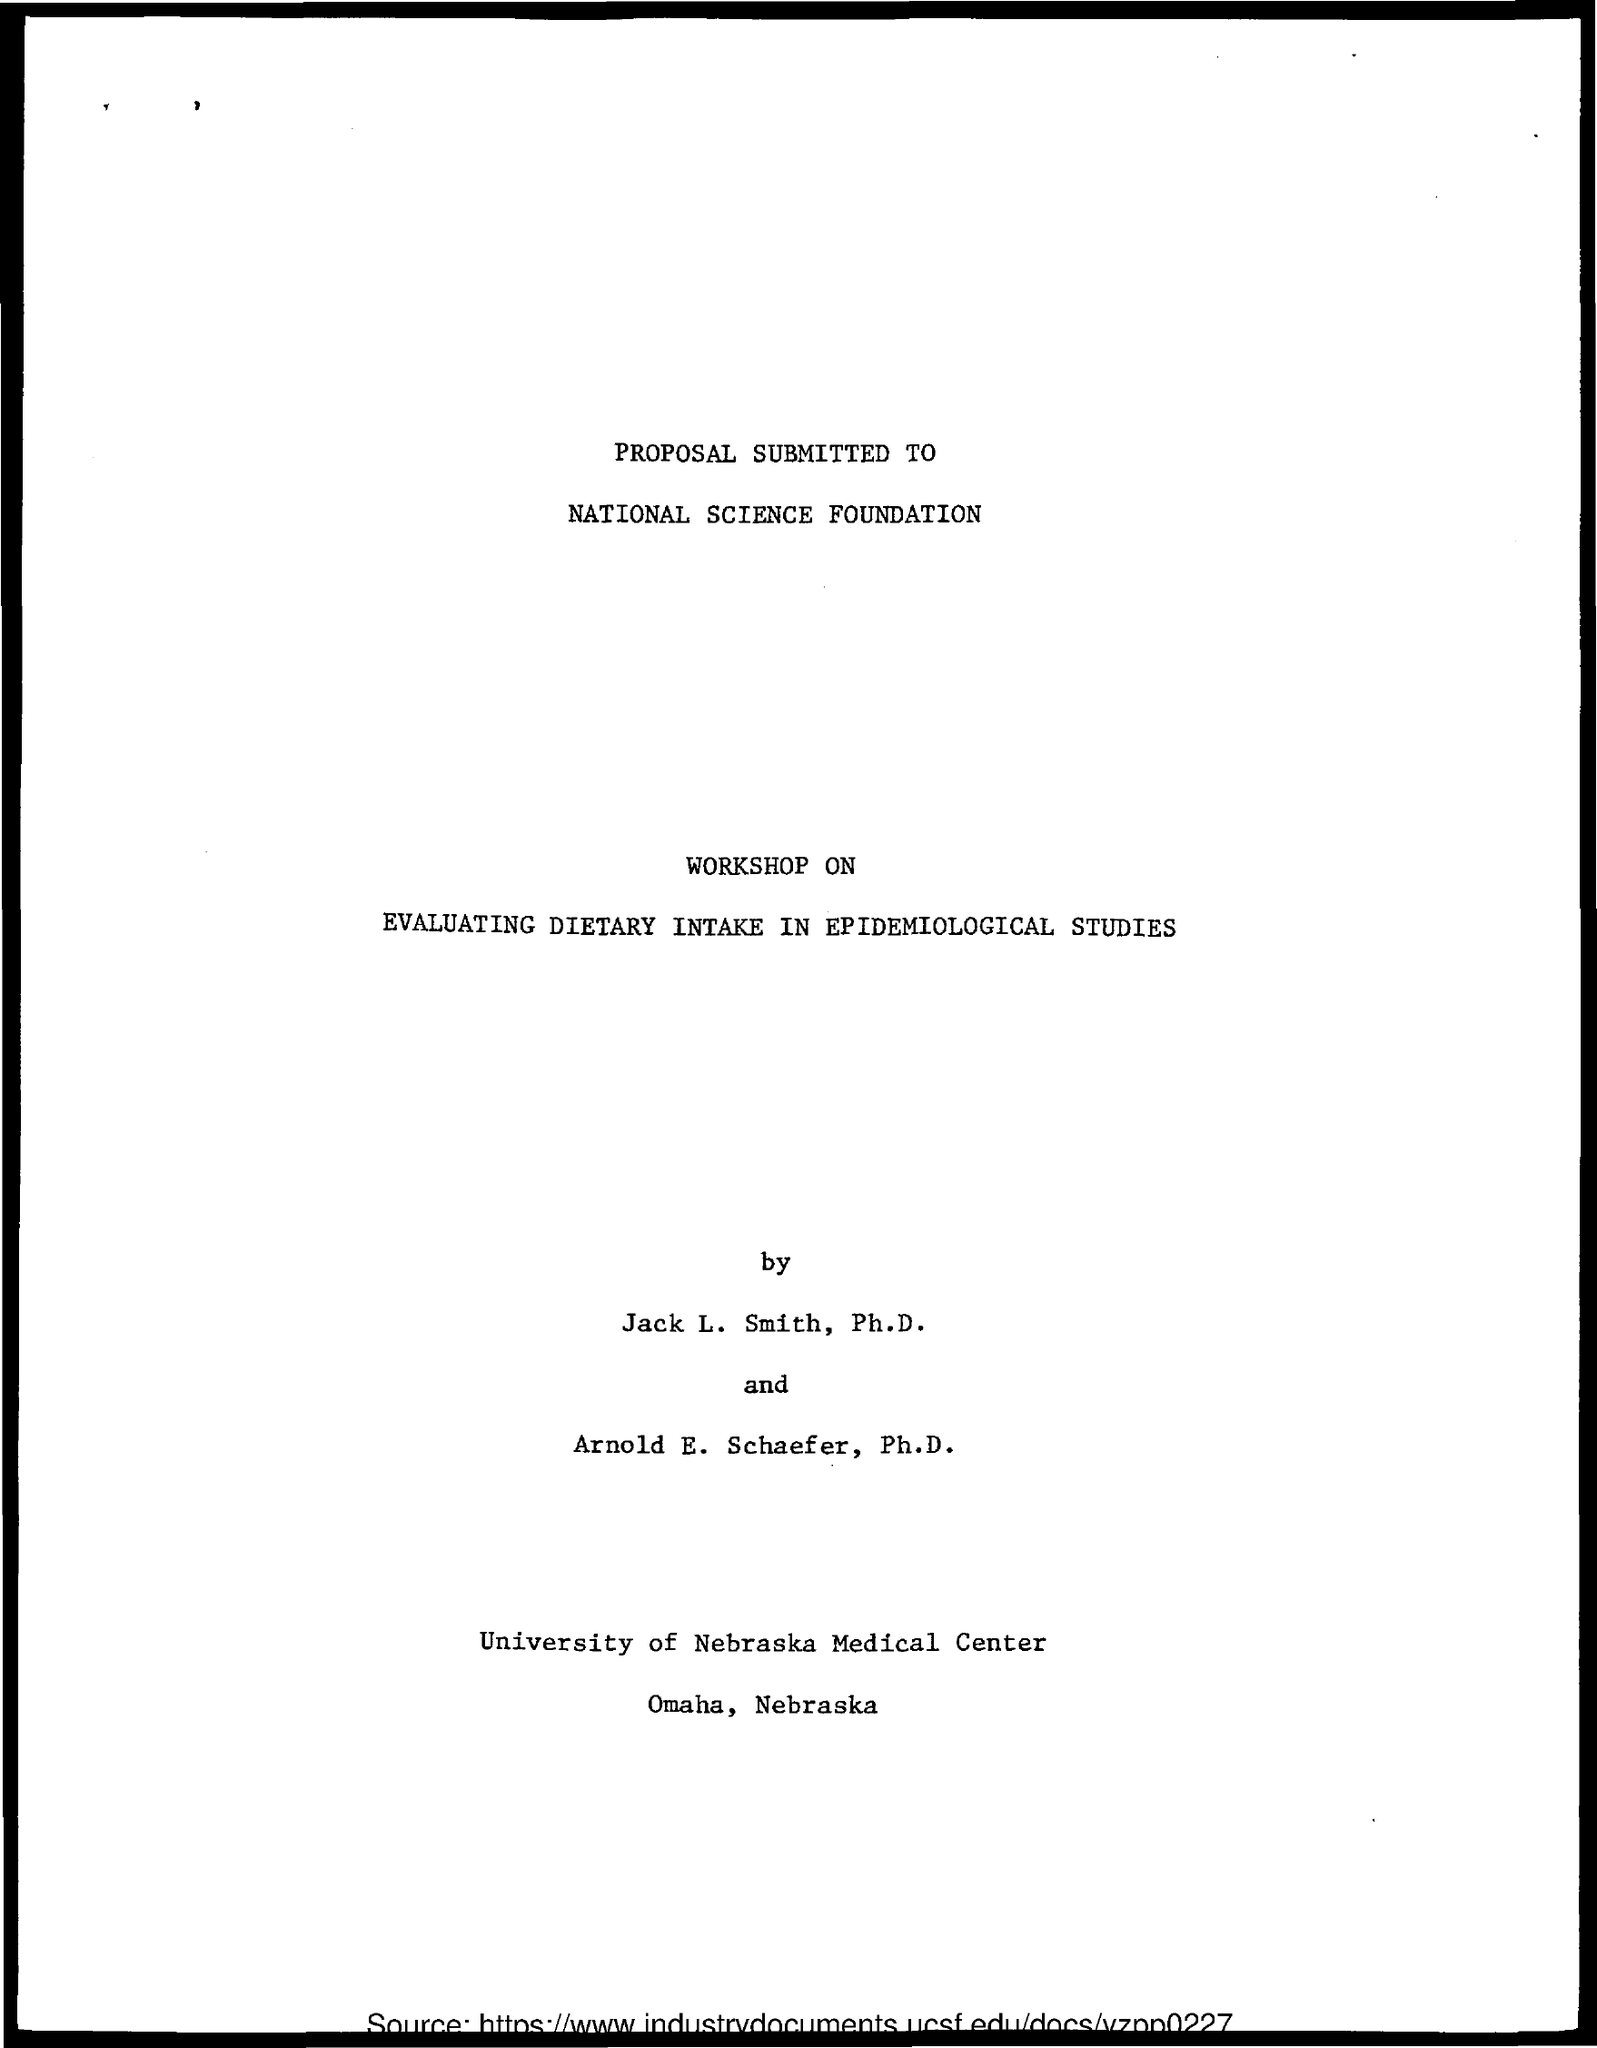What  is the name of the foundation mentioned ?
Keep it short and to the point. NATIONAL SCIENCE FOUNDATION. What is  the workshop based on ?
Make the answer very short. Evaluating dietary intake in epidemiological studies. 